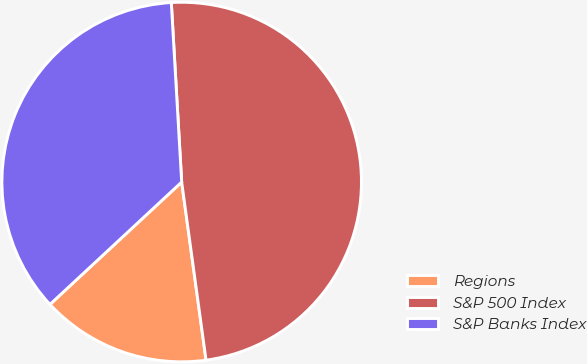Convert chart to OTSL. <chart><loc_0><loc_0><loc_500><loc_500><pie_chart><fcel>Regions<fcel>S&P 500 Index<fcel>S&P Banks Index<nl><fcel>15.25%<fcel>48.76%<fcel>36.0%<nl></chart> 